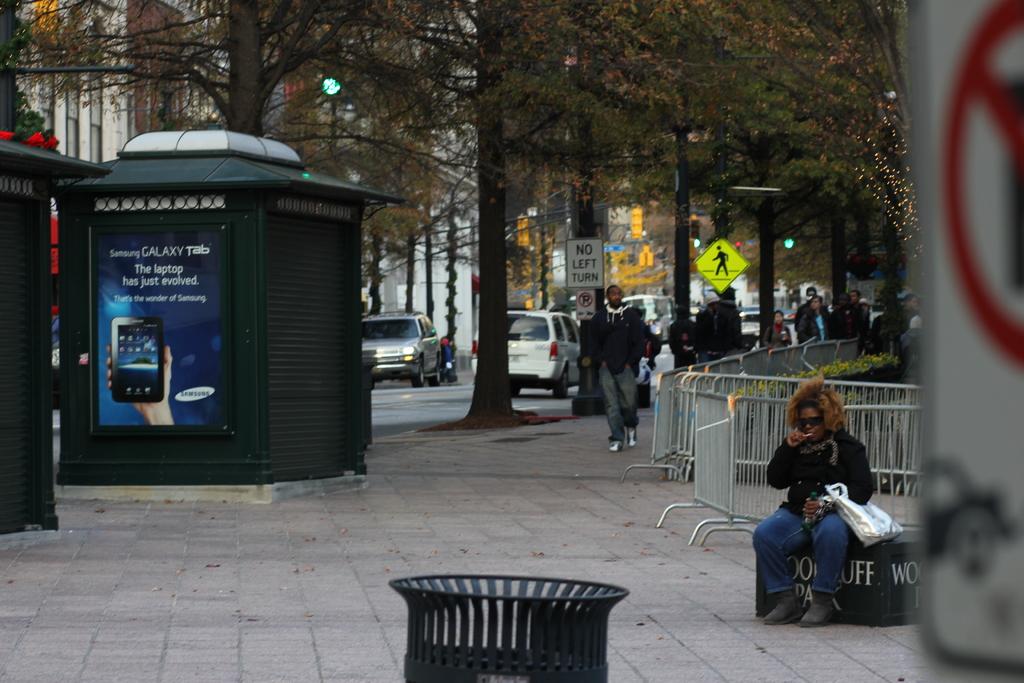What is being advertised?
Make the answer very short. Samsung galaxy tab. Picture is very nice?
Your answer should be compact. Answering does not require reading text in the image. 